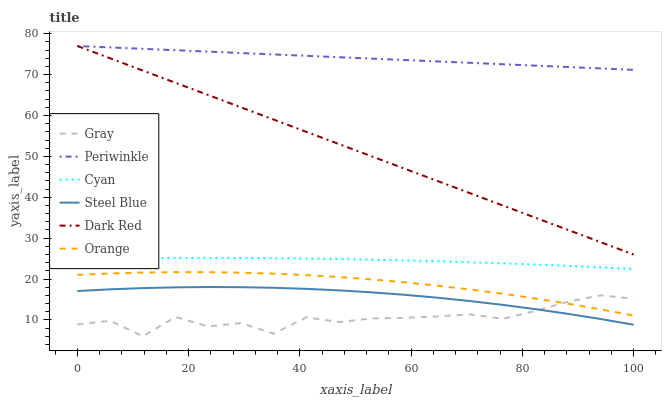Does Dark Red have the minimum area under the curve?
Answer yes or no. No. Does Dark Red have the maximum area under the curve?
Answer yes or no. No. Is Steel Blue the smoothest?
Answer yes or no. No. Is Steel Blue the roughest?
Answer yes or no. No. Does Dark Red have the lowest value?
Answer yes or no. No. Does Steel Blue have the highest value?
Answer yes or no. No. Is Steel Blue less than Cyan?
Answer yes or no. Yes. Is Cyan greater than Orange?
Answer yes or no. Yes. Does Steel Blue intersect Cyan?
Answer yes or no. No. 